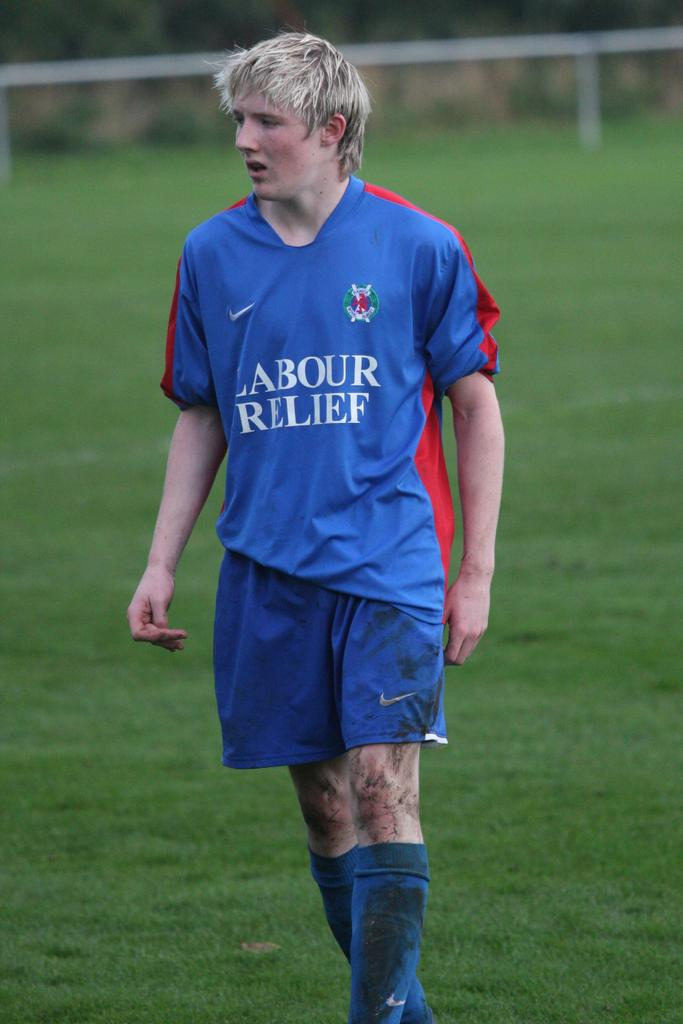<image>
Write a terse but informative summary of the picture. the soccer player is wearing a jersey saying Labour Relief 